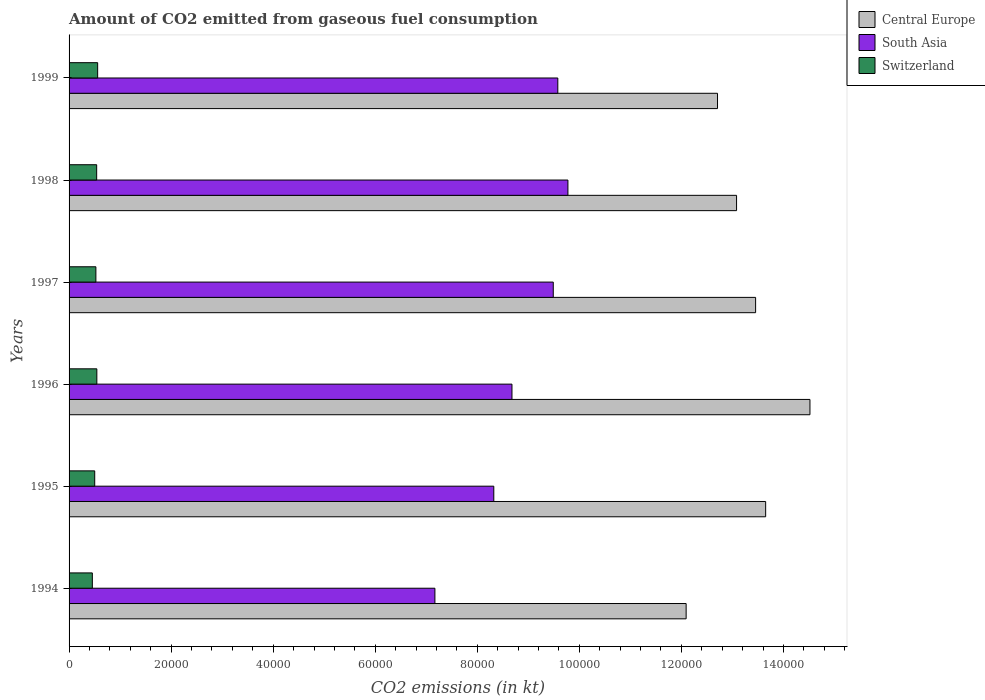How many different coloured bars are there?
Offer a very short reply. 3. How many groups of bars are there?
Offer a terse response. 6. Are the number of bars per tick equal to the number of legend labels?
Give a very brief answer. Yes. Are the number of bars on each tick of the Y-axis equal?
Offer a very short reply. Yes. What is the label of the 5th group of bars from the top?
Ensure brevity in your answer.  1995. In how many cases, is the number of bars for a given year not equal to the number of legend labels?
Ensure brevity in your answer.  0. What is the amount of CO2 emitted in Switzerland in 1995?
Provide a short and direct response. 5027.46. Across all years, what is the maximum amount of CO2 emitted in Switzerland?
Offer a terse response. 5603.18. Across all years, what is the minimum amount of CO2 emitted in Switzerland?
Offer a terse response. 4561.75. In which year was the amount of CO2 emitted in Central Europe minimum?
Provide a succinct answer. 1994. What is the total amount of CO2 emitted in Central Europe in the graph?
Offer a terse response. 7.95e+05. What is the difference between the amount of CO2 emitted in South Asia in 1998 and that in 1999?
Provide a succinct answer. 1981.08. What is the difference between the amount of CO2 emitted in South Asia in 1997 and the amount of CO2 emitted in Central Europe in 1999?
Your answer should be compact. -3.22e+04. What is the average amount of CO2 emitted in South Asia per year?
Your answer should be very brief. 8.84e+04. In the year 1997, what is the difference between the amount of CO2 emitted in South Asia and amount of CO2 emitted in Switzerland?
Give a very brief answer. 8.96e+04. In how many years, is the amount of CO2 emitted in Central Europe greater than 136000 kt?
Provide a short and direct response. 2. What is the ratio of the amount of CO2 emitted in Switzerland in 1994 to that in 1996?
Offer a very short reply. 0.84. Is the amount of CO2 emitted in South Asia in 1997 less than that in 1998?
Your answer should be compact. Yes. Is the difference between the amount of CO2 emitted in South Asia in 1994 and 1999 greater than the difference between the amount of CO2 emitted in Switzerland in 1994 and 1999?
Offer a very short reply. No. What is the difference between the highest and the second highest amount of CO2 emitted in Central Europe?
Make the answer very short. 8679.79. What is the difference between the highest and the lowest amount of CO2 emitted in Switzerland?
Give a very brief answer. 1041.43. In how many years, is the amount of CO2 emitted in Switzerland greater than the average amount of CO2 emitted in Switzerland taken over all years?
Keep it short and to the point. 4. Is the sum of the amount of CO2 emitted in Switzerland in 1994 and 1998 greater than the maximum amount of CO2 emitted in Central Europe across all years?
Ensure brevity in your answer.  No. What does the 3rd bar from the top in 1994 represents?
Provide a short and direct response. Central Europe. What does the 2nd bar from the bottom in 1995 represents?
Your answer should be very brief. South Asia. What is the difference between two consecutive major ticks on the X-axis?
Your response must be concise. 2.00e+04. Does the graph contain any zero values?
Give a very brief answer. No. How many legend labels are there?
Ensure brevity in your answer.  3. What is the title of the graph?
Your answer should be compact. Amount of CO2 emitted from gaseous fuel consumption. What is the label or title of the X-axis?
Ensure brevity in your answer.  CO2 emissions (in kt). What is the CO2 emissions (in kt) in Central Europe in 1994?
Your answer should be very brief. 1.21e+05. What is the CO2 emissions (in kt) in South Asia in 1994?
Keep it short and to the point. 7.17e+04. What is the CO2 emissions (in kt) in Switzerland in 1994?
Ensure brevity in your answer.  4561.75. What is the CO2 emissions (in kt) in Central Europe in 1995?
Provide a succinct answer. 1.37e+05. What is the CO2 emissions (in kt) in South Asia in 1995?
Give a very brief answer. 8.32e+04. What is the CO2 emissions (in kt) of Switzerland in 1995?
Offer a very short reply. 5027.46. What is the CO2 emissions (in kt) in Central Europe in 1996?
Your answer should be compact. 1.45e+05. What is the CO2 emissions (in kt) of South Asia in 1996?
Give a very brief answer. 8.68e+04. What is the CO2 emissions (in kt) in Switzerland in 1996?
Offer a terse response. 5441.83. What is the CO2 emissions (in kt) in Central Europe in 1997?
Provide a succinct answer. 1.35e+05. What is the CO2 emissions (in kt) in South Asia in 1997?
Your answer should be compact. 9.49e+04. What is the CO2 emissions (in kt) in Switzerland in 1997?
Your answer should be compact. 5254.81. What is the CO2 emissions (in kt) of Central Europe in 1998?
Ensure brevity in your answer.  1.31e+05. What is the CO2 emissions (in kt) of South Asia in 1998?
Give a very brief answer. 9.78e+04. What is the CO2 emissions (in kt) in Switzerland in 1998?
Offer a very short reply. 5408.82. What is the CO2 emissions (in kt) of Central Europe in 1999?
Make the answer very short. 1.27e+05. What is the CO2 emissions (in kt) of South Asia in 1999?
Keep it short and to the point. 9.58e+04. What is the CO2 emissions (in kt) of Switzerland in 1999?
Your answer should be compact. 5603.18. Across all years, what is the maximum CO2 emissions (in kt) in Central Europe?
Your answer should be very brief. 1.45e+05. Across all years, what is the maximum CO2 emissions (in kt) of South Asia?
Offer a very short reply. 9.78e+04. Across all years, what is the maximum CO2 emissions (in kt) in Switzerland?
Your answer should be very brief. 5603.18. Across all years, what is the minimum CO2 emissions (in kt) of Central Europe?
Your response must be concise. 1.21e+05. Across all years, what is the minimum CO2 emissions (in kt) in South Asia?
Your answer should be compact. 7.17e+04. Across all years, what is the minimum CO2 emissions (in kt) of Switzerland?
Offer a terse response. 4561.75. What is the total CO2 emissions (in kt) of Central Europe in the graph?
Make the answer very short. 7.95e+05. What is the total CO2 emissions (in kt) of South Asia in the graph?
Keep it short and to the point. 5.30e+05. What is the total CO2 emissions (in kt) in Switzerland in the graph?
Provide a short and direct response. 3.13e+04. What is the difference between the CO2 emissions (in kt) of Central Europe in 1994 and that in 1995?
Keep it short and to the point. -1.56e+04. What is the difference between the CO2 emissions (in kt) of South Asia in 1994 and that in 1995?
Your answer should be very brief. -1.15e+04. What is the difference between the CO2 emissions (in kt) in Switzerland in 1994 and that in 1995?
Make the answer very short. -465.71. What is the difference between the CO2 emissions (in kt) in Central Europe in 1994 and that in 1996?
Your answer should be very brief. -2.43e+04. What is the difference between the CO2 emissions (in kt) of South Asia in 1994 and that in 1996?
Offer a very short reply. -1.51e+04. What is the difference between the CO2 emissions (in kt) in Switzerland in 1994 and that in 1996?
Your response must be concise. -880.08. What is the difference between the CO2 emissions (in kt) in Central Europe in 1994 and that in 1997?
Keep it short and to the point. -1.36e+04. What is the difference between the CO2 emissions (in kt) in South Asia in 1994 and that in 1997?
Make the answer very short. -2.32e+04. What is the difference between the CO2 emissions (in kt) in Switzerland in 1994 and that in 1997?
Offer a terse response. -693.06. What is the difference between the CO2 emissions (in kt) in Central Europe in 1994 and that in 1998?
Keep it short and to the point. -9882.57. What is the difference between the CO2 emissions (in kt) of South Asia in 1994 and that in 1998?
Your answer should be very brief. -2.61e+04. What is the difference between the CO2 emissions (in kt) of Switzerland in 1994 and that in 1998?
Make the answer very short. -847.08. What is the difference between the CO2 emissions (in kt) of Central Europe in 1994 and that in 1999?
Keep it short and to the point. -6149.56. What is the difference between the CO2 emissions (in kt) in South Asia in 1994 and that in 1999?
Your response must be concise. -2.41e+04. What is the difference between the CO2 emissions (in kt) of Switzerland in 1994 and that in 1999?
Your answer should be very brief. -1041.43. What is the difference between the CO2 emissions (in kt) of Central Europe in 1995 and that in 1996?
Your answer should be compact. -8679.79. What is the difference between the CO2 emissions (in kt) in South Asia in 1995 and that in 1996?
Ensure brevity in your answer.  -3560.65. What is the difference between the CO2 emissions (in kt) of Switzerland in 1995 and that in 1996?
Offer a very short reply. -414.37. What is the difference between the CO2 emissions (in kt) of Central Europe in 1995 and that in 1997?
Give a very brief answer. 1969.18. What is the difference between the CO2 emissions (in kt) in South Asia in 1995 and that in 1997?
Your answer should be compact. -1.17e+04. What is the difference between the CO2 emissions (in kt) in Switzerland in 1995 and that in 1997?
Keep it short and to the point. -227.35. What is the difference between the CO2 emissions (in kt) of Central Europe in 1995 and that in 1998?
Give a very brief answer. 5702.19. What is the difference between the CO2 emissions (in kt) in South Asia in 1995 and that in 1998?
Give a very brief answer. -1.45e+04. What is the difference between the CO2 emissions (in kt) of Switzerland in 1995 and that in 1998?
Provide a succinct answer. -381.37. What is the difference between the CO2 emissions (in kt) in Central Europe in 1995 and that in 1999?
Keep it short and to the point. 9435.19. What is the difference between the CO2 emissions (in kt) in South Asia in 1995 and that in 1999?
Ensure brevity in your answer.  -1.25e+04. What is the difference between the CO2 emissions (in kt) in Switzerland in 1995 and that in 1999?
Make the answer very short. -575.72. What is the difference between the CO2 emissions (in kt) of Central Europe in 1996 and that in 1997?
Provide a short and direct response. 1.06e+04. What is the difference between the CO2 emissions (in kt) of South Asia in 1996 and that in 1997?
Keep it short and to the point. -8094.79. What is the difference between the CO2 emissions (in kt) of Switzerland in 1996 and that in 1997?
Give a very brief answer. 187.02. What is the difference between the CO2 emissions (in kt) in Central Europe in 1996 and that in 1998?
Give a very brief answer. 1.44e+04. What is the difference between the CO2 emissions (in kt) in South Asia in 1996 and that in 1998?
Offer a terse response. -1.10e+04. What is the difference between the CO2 emissions (in kt) of Switzerland in 1996 and that in 1998?
Provide a succinct answer. 33. What is the difference between the CO2 emissions (in kt) in Central Europe in 1996 and that in 1999?
Keep it short and to the point. 1.81e+04. What is the difference between the CO2 emissions (in kt) of South Asia in 1996 and that in 1999?
Make the answer very short. -8984.95. What is the difference between the CO2 emissions (in kt) of Switzerland in 1996 and that in 1999?
Offer a very short reply. -161.35. What is the difference between the CO2 emissions (in kt) in Central Europe in 1997 and that in 1998?
Your answer should be compact. 3733.01. What is the difference between the CO2 emissions (in kt) in South Asia in 1997 and that in 1998?
Give a very brief answer. -2871.24. What is the difference between the CO2 emissions (in kt) in Switzerland in 1997 and that in 1998?
Your answer should be very brief. -154.01. What is the difference between the CO2 emissions (in kt) of Central Europe in 1997 and that in 1999?
Provide a succinct answer. 7466.01. What is the difference between the CO2 emissions (in kt) in South Asia in 1997 and that in 1999?
Your answer should be very brief. -890.16. What is the difference between the CO2 emissions (in kt) in Switzerland in 1997 and that in 1999?
Make the answer very short. -348.37. What is the difference between the CO2 emissions (in kt) in Central Europe in 1998 and that in 1999?
Make the answer very short. 3733.01. What is the difference between the CO2 emissions (in kt) of South Asia in 1998 and that in 1999?
Offer a terse response. 1981.08. What is the difference between the CO2 emissions (in kt) of Switzerland in 1998 and that in 1999?
Offer a very short reply. -194.35. What is the difference between the CO2 emissions (in kt) in Central Europe in 1994 and the CO2 emissions (in kt) in South Asia in 1995?
Provide a short and direct response. 3.77e+04. What is the difference between the CO2 emissions (in kt) in Central Europe in 1994 and the CO2 emissions (in kt) in Switzerland in 1995?
Ensure brevity in your answer.  1.16e+05. What is the difference between the CO2 emissions (in kt) of South Asia in 1994 and the CO2 emissions (in kt) of Switzerland in 1995?
Ensure brevity in your answer.  6.67e+04. What is the difference between the CO2 emissions (in kt) of Central Europe in 1994 and the CO2 emissions (in kt) of South Asia in 1996?
Your response must be concise. 3.41e+04. What is the difference between the CO2 emissions (in kt) of Central Europe in 1994 and the CO2 emissions (in kt) of Switzerland in 1996?
Your answer should be compact. 1.15e+05. What is the difference between the CO2 emissions (in kt) in South Asia in 1994 and the CO2 emissions (in kt) in Switzerland in 1996?
Your answer should be compact. 6.63e+04. What is the difference between the CO2 emissions (in kt) in Central Europe in 1994 and the CO2 emissions (in kt) in South Asia in 1997?
Give a very brief answer. 2.60e+04. What is the difference between the CO2 emissions (in kt) of Central Europe in 1994 and the CO2 emissions (in kt) of Switzerland in 1997?
Your answer should be compact. 1.16e+05. What is the difference between the CO2 emissions (in kt) of South Asia in 1994 and the CO2 emissions (in kt) of Switzerland in 1997?
Offer a terse response. 6.64e+04. What is the difference between the CO2 emissions (in kt) of Central Europe in 1994 and the CO2 emissions (in kt) of South Asia in 1998?
Your answer should be compact. 2.32e+04. What is the difference between the CO2 emissions (in kt) of Central Europe in 1994 and the CO2 emissions (in kt) of Switzerland in 1998?
Provide a succinct answer. 1.16e+05. What is the difference between the CO2 emissions (in kt) of South Asia in 1994 and the CO2 emissions (in kt) of Switzerland in 1998?
Your answer should be very brief. 6.63e+04. What is the difference between the CO2 emissions (in kt) in Central Europe in 1994 and the CO2 emissions (in kt) in South Asia in 1999?
Your response must be concise. 2.51e+04. What is the difference between the CO2 emissions (in kt) in Central Europe in 1994 and the CO2 emissions (in kt) in Switzerland in 1999?
Provide a short and direct response. 1.15e+05. What is the difference between the CO2 emissions (in kt) in South Asia in 1994 and the CO2 emissions (in kt) in Switzerland in 1999?
Give a very brief answer. 6.61e+04. What is the difference between the CO2 emissions (in kt) of Central Europe in 1995 and the CO2 emissions (in kt) of South Asia in 1996?
Provide a succinct answer. 4.97e+04. What is the difference between the CO2 emissions (in kt) in Central Europe in 1995 and the CO2 emissions (in kt) in Switzerland in 1996?
Give a very brief answer. 1.31e+05. What is the difference between the CO2 emissions (in kt) of South Asia in 1995 and the CO2 emissions (in kt) of Switzerland in 1996?
Provide a succinct answer. 7.78e+04. What is the difference between the CO2 emissions (in kt) of Central Europe in 1995 and the CO2 emissions (in kt) of South Asia in 1997?
Offer a very short reply. 4.16e+04. What is the difference between the CO2 emissions (in kt) in Central Europe in 1995 and the CO2 emissions (in kt) in Switzerland in 1997?
Offer a terse response. 1.31e+05. What is the difference between the CO2 emissions (in kt) of South Asia in 1995 and the CO2 emissions (in kt) of Switzerland in 1997?
Provide a short and direct response. 7.80e+04. What is the difference between the CO2 emissions (in kt) of Central Europe in 1995 and the CO2 emissions (in kt) of South Asia in 1998?
Your response must be concise. 3.88e+04. What is the difference between the CO2 emissions (in kt) in Central Europe in 1995 and the CO2 emissions (in kt) in Switzerland in 1998?
Give a very brief answer. 1.31e+05. What is the difference between the CO2 emissions (in kt) in South Asia in 1995 and the CO2 emissions (in kt) in Switzerland in 1998?
Offer a terse response. 7.78e+04. What is the difference between the CO2 emissions (in kt) in Central Europe in 1995 and the CO2 emissions (in kt) in South Asia in 1999?
Your response must be concise. 4.07e+04. What is the difference between the CO2 emissions (in kt) of Central Europe in 1995 and the CO2 emissions (in kt) of Switzerland in 1999?
Offer a very short reply. 1.31e+05. What is the difference between the CO2 emissions (in kt) in South Asia in 1995 and the CO2 emissions (in kt) in Switzerland in 1999?
Keep it short and to the point. 7.76e+04. What is the difference between the CO2 emissions (in kt) in Central Europe in 1996 and the CO2 emissions (in kt) in South Asia in 1997?
Your answer should be very brief. 5.03e+04. What is the difference between the CO2 emissions (in kt) of Central Europe in 1996 and the CO2 emissions (in kt) of Switzerland in 1997?
Your answer should be compact. 1.40e+05. What is the difference between the CO2 emissions (in kt) in South Asia in 1996 and the CO2 emissions (in kt) in Switzerland in 1997?
Make the answer very short. 8.15e+04. What is the difference between the CO2 emissions (in kt) in Central Europe in 1996 and the CO2 emissions (in kt) in South Asia in 1998?
Offer a terse response. 4.74e+04. What is the difference between the CO2 emissions (in kt) in Central Europe in 1996 and the CO2 emissions (in kt) in Switzerland in 1998?
Ensure brevity in your answer.  1.40e+05. What is the difference between the CO2 emissions (in kt) of South Asia in 1996 and the CO2 emissions (in kt) of Switzerland in 1998?
Offer a terse response. 8.14e+04. What is the difference between the CO2 emissions (in kt) in Central Europe in 1996 and the CO2 emissions (in kt) in South Asia in 1999?
Give a very brief answer. 4.94e+04. What is the difference between the CO2 emissions (in kt) in Central Europe in 1996 and the CO2 emissions (in kt) in Switzerland in 1999?
Offer a terse response. 1.40e+05. What is the difference between the CO2 emissions (in kt) of South Asia in 1996 and the CO2 emissions (in kt) of Switzerland in 1999?
Ensure brevity in your answer.  8.12e+04. What is the difference between the CO2 emissions (in kt) of Central Europe in 1997 and the CO2 emissions (in kt) of South Asia in 1998?
Provide a succinct answer. 3.68e+04. What is the difference between the CO2 emissions (in kt) of Central Europe in 1997 and the CO2 emissions (in kt) of Switzerland in 1998?
Your answer should be very brief. 1.29e+05. What is the difference between the CO2 emissions (in kt) in South Asia in 1997 and the CO2 emissions (in kt) in Switzerland in 1998?
Give a very brief answer. 8.95e+04. What is the difference between the CO2 emissions (in kt) in Central Europe in 1997 and the CO2 emissions (in kt) in South Asia in 1999?
Provide a short and direct response. 3.88e+04. What is the difference between the CO2 emissions (in kt) of Central Europe in 1997 and the CO2 emissions (in kt) of Switzerland in 1999?
Offer a very short reply. 1.29e+05. What is the difference between the CO2 emissions (in kt) in South Asia in 1997 and the CO2 emissions (in kt) in Switzerland in 1999?
Offer a terse response. 8.93e+04. What is the difference between the CO2 emissions (in kt) of Central Europe in 1998 and the CO2 emissions (in kt) of South Asia in 1999?
Offer a terse response. 3.50e+04. What is the difference between the CO2 emissions (in kt) of Central Europe in 1998 and the CO2 emissions (in kt) of Switzerland in 1999?
Ensure brevity in your answer.  1.25e+05. What is the difference between the CO2 emissions (in kt) of South Asia in 1998 and the CO2 emissions (in kt) of Switzerland in 1999?
Your answer should be compact. 9.22e+04. What is the average CO2 emissions (in kt) of Central Europe per year?
Offer a very short reply. 1.33e+05. What is the average CO2 emissions (in kt) of South Asia per year?
Make the answer very short. 8.84e+04. What is the average CO2 emissions (in kt) in Switzerland per year?
Provide a short and direct response. 5216.31. In the year 1994, what is the difference between the CO2 emissions (in kt) in Central Europe and CO2 emissions (in kt) in South Asia?
Keep it short and to the point. 4.92e+04. In the year 1994, what is the difference between the CO2 emissions (in kt) in Central Europe and CO2 emissions (in kt) in Switzerland?
Make the answer very short. 1.16e+05. In the year 1994, what is the difference between the CO2 emissions (in kt) of South Asia and CO2 emissions (in kt) of Switzerland?
Give a very brief answer. 6.71e+04. In the year 1995, what is the difference between the CO2 emissions (in kt) of Central Europe and CO2 emissions (in kt) of South Asia?
Your answer should be compact. 5.33e+04. In the year 1995, what is the difference between the CO2 emissions (in kt) of Central Europe and CO2 emissions (in kt) of Switzerland?
Your answer should be very brief. 1.31e+05. In the year 1995, what is the difference between the CO2 emissions (in kt) of South Asia and CO2 emissions (in kt) of Switzerland?
Provide a succinct answer. 7.82e+04. In the year 1996, what is the difference between the CO2 emissions (in kt) of Central Europe and CO2 emissions (in kt) of South Asia?
Your answer should be compact. 5.84e+04. In the year 1996, what is the difference between the CO2 emissions (in kt) of Central Europe and CO2 emissions (in kt) of Switzerland?
Provide a short and direct response. 1.40e+05. In the year 1996, what is the difference between the CO2 emissions (in kt) in South Asia and CO2 emissions (in kt) in Switzerland?
Ensure brevity in your answer.  8.14e+04. In the year 1997, what is the difference between the CO2 emissions (in kt) in Central Europe and CO2 emissions (in kt) in South Asia?
Ensure brevity in your answer.  3.97e+04. In the year 1997, what is the difference between the CO2 emissions (in kt) of Central Europe and CO2 emissions (in kt) of Switzerland?
Make the answer very short. 1.29e+05. In the year 1997, what is the difference between the CO2 emissions (in kt) of South Asia and CO2 emissions (in kt) of Switzerland?
Keep it short and to the point. 8.96e+04. In the year 1998, what is the difference between the CO2 emissions (in kt) of Central Europe and CO2 emissions (in kt) of South Asia?
Provide a succinct answer. 3.31e+04. In the year 1998, what is the difference between the CO2 emissions (in kt) of Central Europe and CO2 emissions (in kt) of Switzerland?
Keep it short and to the point. 1.25e+05. In the year 1998, what is the difference between the CO2 emissions (in kt) of South Asia and CO2 emissions (in kt) of Switzerland?
Ensure brevity in your answer.  9.24e+04. In the year 1999, what is the difference between the CO2 emissions (in kt) in Central Europe and CO2 emissions (in kt) in South Asia?
Provide a succinct answer. 3.13e+04. In the year 1999, what is the difference between the CO2 emissions (in kt) of Central Europe and CO2 emissions (in kt) of Switzerland?
Offer a terse response. 1.21e+05. In the year 1999, what is the difference between the CO2 emissions (in kt) in South Asia and CO2 emissions (in kt) in Switzerland?
Your answer should be very brief. 9.02e+04. What is the ratio of the CO2 emissions (in kt) of Central Europe in 1994 to that in 1995?
Your response must be concise. 0.89. What is the ratio of the CO2 emissions (in kt) in South Asia in 1994 to that in 1995?
Keep it short and to the point. 0.86. What is the ratio of the CO2 emissions (in kt) in Switzerland in 1994 to that in 1995?
Your response must be concise. 0.91. What is the ratio of the CO2 emissions (in kt) in Central Europe in 1994 to that in 1996?
Offer a very short reply. 0.83. What is the ratio of the CO2 emissions (in kt) in South Asia in 1994 to that in 1996?
Make the answer very short. 0.83. What is the ratio of the CO2 emissions (in kt) of Switzerland in 1994 to that in 1996?
Your response must be concise. 0.84. What is the ratio of the CO2 emissions (in kt) in Central Europe in 1994 to that in 1997?
Give a very brief answer. 0.9. What is the ratio of the CO2 emissions (in kt) of South Asia in 1994 to that in 1997?
Your response must be concise. 0.76. What is the ratio of the CO2 emissions (in kt) in Switzerland in 1994 to that in 1997?
Your answer should be compact. 0.87. What is the ratio of the CO2 emissions (in kt) of Central Europe in 1994 to that in 1998?
Offer a terse response. 0.92. What is the ratio of the CO2 emissions (in kt) in South Asia in 1994 to that in 1998?
Provide a succinct answer. 0.73. What is the ratio of the CO2 emissions (in kt) in Switzerland in 1994 to that in 1998?
Your response must be concise. 0.84. What is the ratio of the CO2 emissions (in kt) of Central Europe in 1994 to that in 1999?
Make the answer very short. 0.95. What is the ratio of the CO2 emissions (in kt) of South Asia in 1994 to that in 1999?
Offer a terse response. 0.75. What is the ratio of the CO2 emissions (in kt) in Switzerland in 1994 to that in 1999?
Your answer should be very brief. 0.81. What is the ratio of the CO2 emissions (in kt) of Central Europe in 1995 to that in 1996?
Offer a very short reply. 0.94. What is the ratio of the CO2 emissions (in kt) of South Asia in 1995 to that in 1996?
Make the answer very short. 0.96. What is the ratio of the CO2 emissions (in kt) in Switzerland in 1995 to that in 1996?
Offer a terse response. 0.92. What is the ratio of the CO2 emissions (in kt) in Central Europe in 1995 to that in 1997?
Your response must be concise. 1.01. What is the ratio of the CO2 emissions (in kt) of South Asia in 1995 to that in 1997?
Keep it short and to the point. 0.88. What is the ratio of the CO2 emissions (in kt) in Switzerland in 1995 to that in 1997?
Offer a very short reply. 0.96. What is the ratio of the CO2 emissions (in kt) of Central Europe in 1995 to that in 1998?
Offer a terse response. 1.04. What is the ratio of the CO2 emissions (in kt) in South Asia in 1995 to that in 1998?
Your answer should be compact. 0.85. What is the ratio of the CO2 emissions (in kt) in Switzerland in 1995 to that in 1998?
Your answer should be compact. 0.93. What is the ratio of the CO2 emissions (in kt) in Central Europe in 1995 to that in 1999?
Give a very brief answer. 1.07. What is the ratio of the CO2 emissions (in kt) of South Asia in 1995 to that in 1999?
Your response must be concise. 0.87. What is the ratio of the CO2 emissions (in kt) of Switzerland in 1995 to that in 1999?
Make the answer very short. 0.9. What is the ratio of the CO2 emissions (in kt) of Central Europe in 1996 to that in 1997?
Ensure brevity in your answer.  1.08. What is the ratio of the CO2 emissions (in kt) of South Asia in 1996 to that in 1997?
Make the answer very short. 0.91. What is the ratio of the CO2 emissions (in kt) of Switzerland in 1996 to that in 1997?
Provide a succinct answer. 1.04. What is the ratio of the CO2 emissions (in kt) in Central Europe in 1996 to that in 1998?
Keep it short and to the point. 1.11. What is the ratio of the CO2 emissions (in kt) of South Asia in 1996 to that in 1998?
Your answer should be very brief. 0.89. What is the ratio of the CO2 emissions (in kt) of Switzerland in 1996 to that in 1998?
Provide a short and direct response. 1.01. What is the ratio of the CO2 emissions (in kt) of Central Europe in 1996 to that in 1999?
Your answer should be compact. 1.14. What is the ratio of the CO2 emissions (in kt) in South Asia in 1996 to that in 1999?
Make the answer very short. 0.91. What is the ratio of the CO2 emissions (in kt) of Switzerland in 1996 to that in 1999?
Your response must be concise. 0.97. What is the ratio of the CO2 emissions (in kt) in Central Europe in 1997 to that in 1998?
Ensure brevity in your answer.  1.03. What is the ratio of the CO2 emissions (in kt) of South Asia in 1997 to that in 1998?
Make the answer very short. 0.97. What is the ratio of the CO2 emissions (in kt) of Switzerland in 1997 to that in 1998?
Make the answer very short. 0.97. What is the ratio of the CO2 emissions (in kt) in Central Europe in 1997 to that in 1999?
Your answer should be very brief. 1.06. What is the ratio of the CO2 emissions (in kt) of Switzerland in 1997 to that in 1999?
Make the answer very short. 0.94. What is the ratio of the CO2 emissions (in kt) of Central Europe in 1998 to that in 1999?
Your answer should be very brief. 1.03. What is the ratio of the CO2 emissions (in kt) of South Asia in 1998 to that in 1999?
Your answer should be compact. 1.02. What is the ratio of the CO2 emissions (in kt) of Switzerland in 1998 to that in 1999?
Your answer should be very brief. 0.97. What is the difference between the highest and the second highest CO2 emissions (in kt) in Central Europe?
Offer a very short reply. 8679.79. What is the difference between the highest and the second highest CO2 emissions (in kt) in South Asia?
Offer a very short reply. 1981.08. What is the difference between the highest and the second highest CO2 emissions (in kt) in Switzerland?
Your response must be concise. 161.35. What is the difference between the highest and the lowest CO2 emissions (in kt) of Central Europe?
Offer a very short reply. 2.43e+04. What is the difference between the highest and the lowest CO2 emissions (in kt) of South Asia?
Your answer should be very brief. 2.61e+04. What is the difference between the highest and the lowest CO2 emissions (in kt) of Switzerland?
Give a very brief answer. 1041.43. 